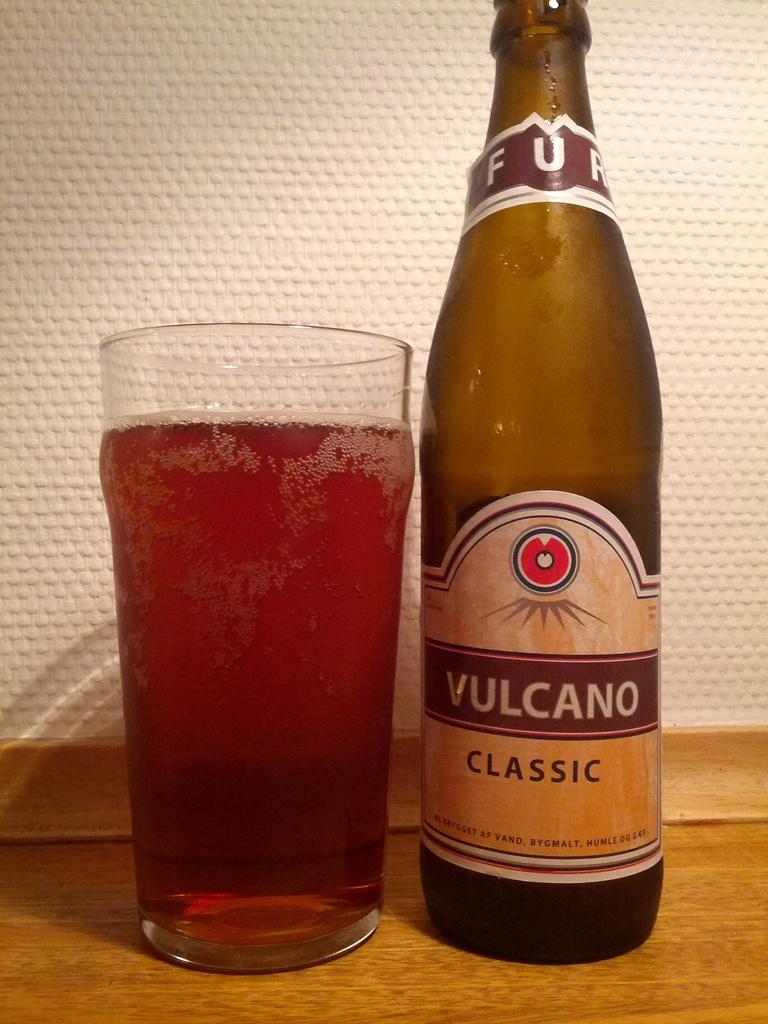Is this a bottle of vulcano?
Keep it short and to the point. Yes. 